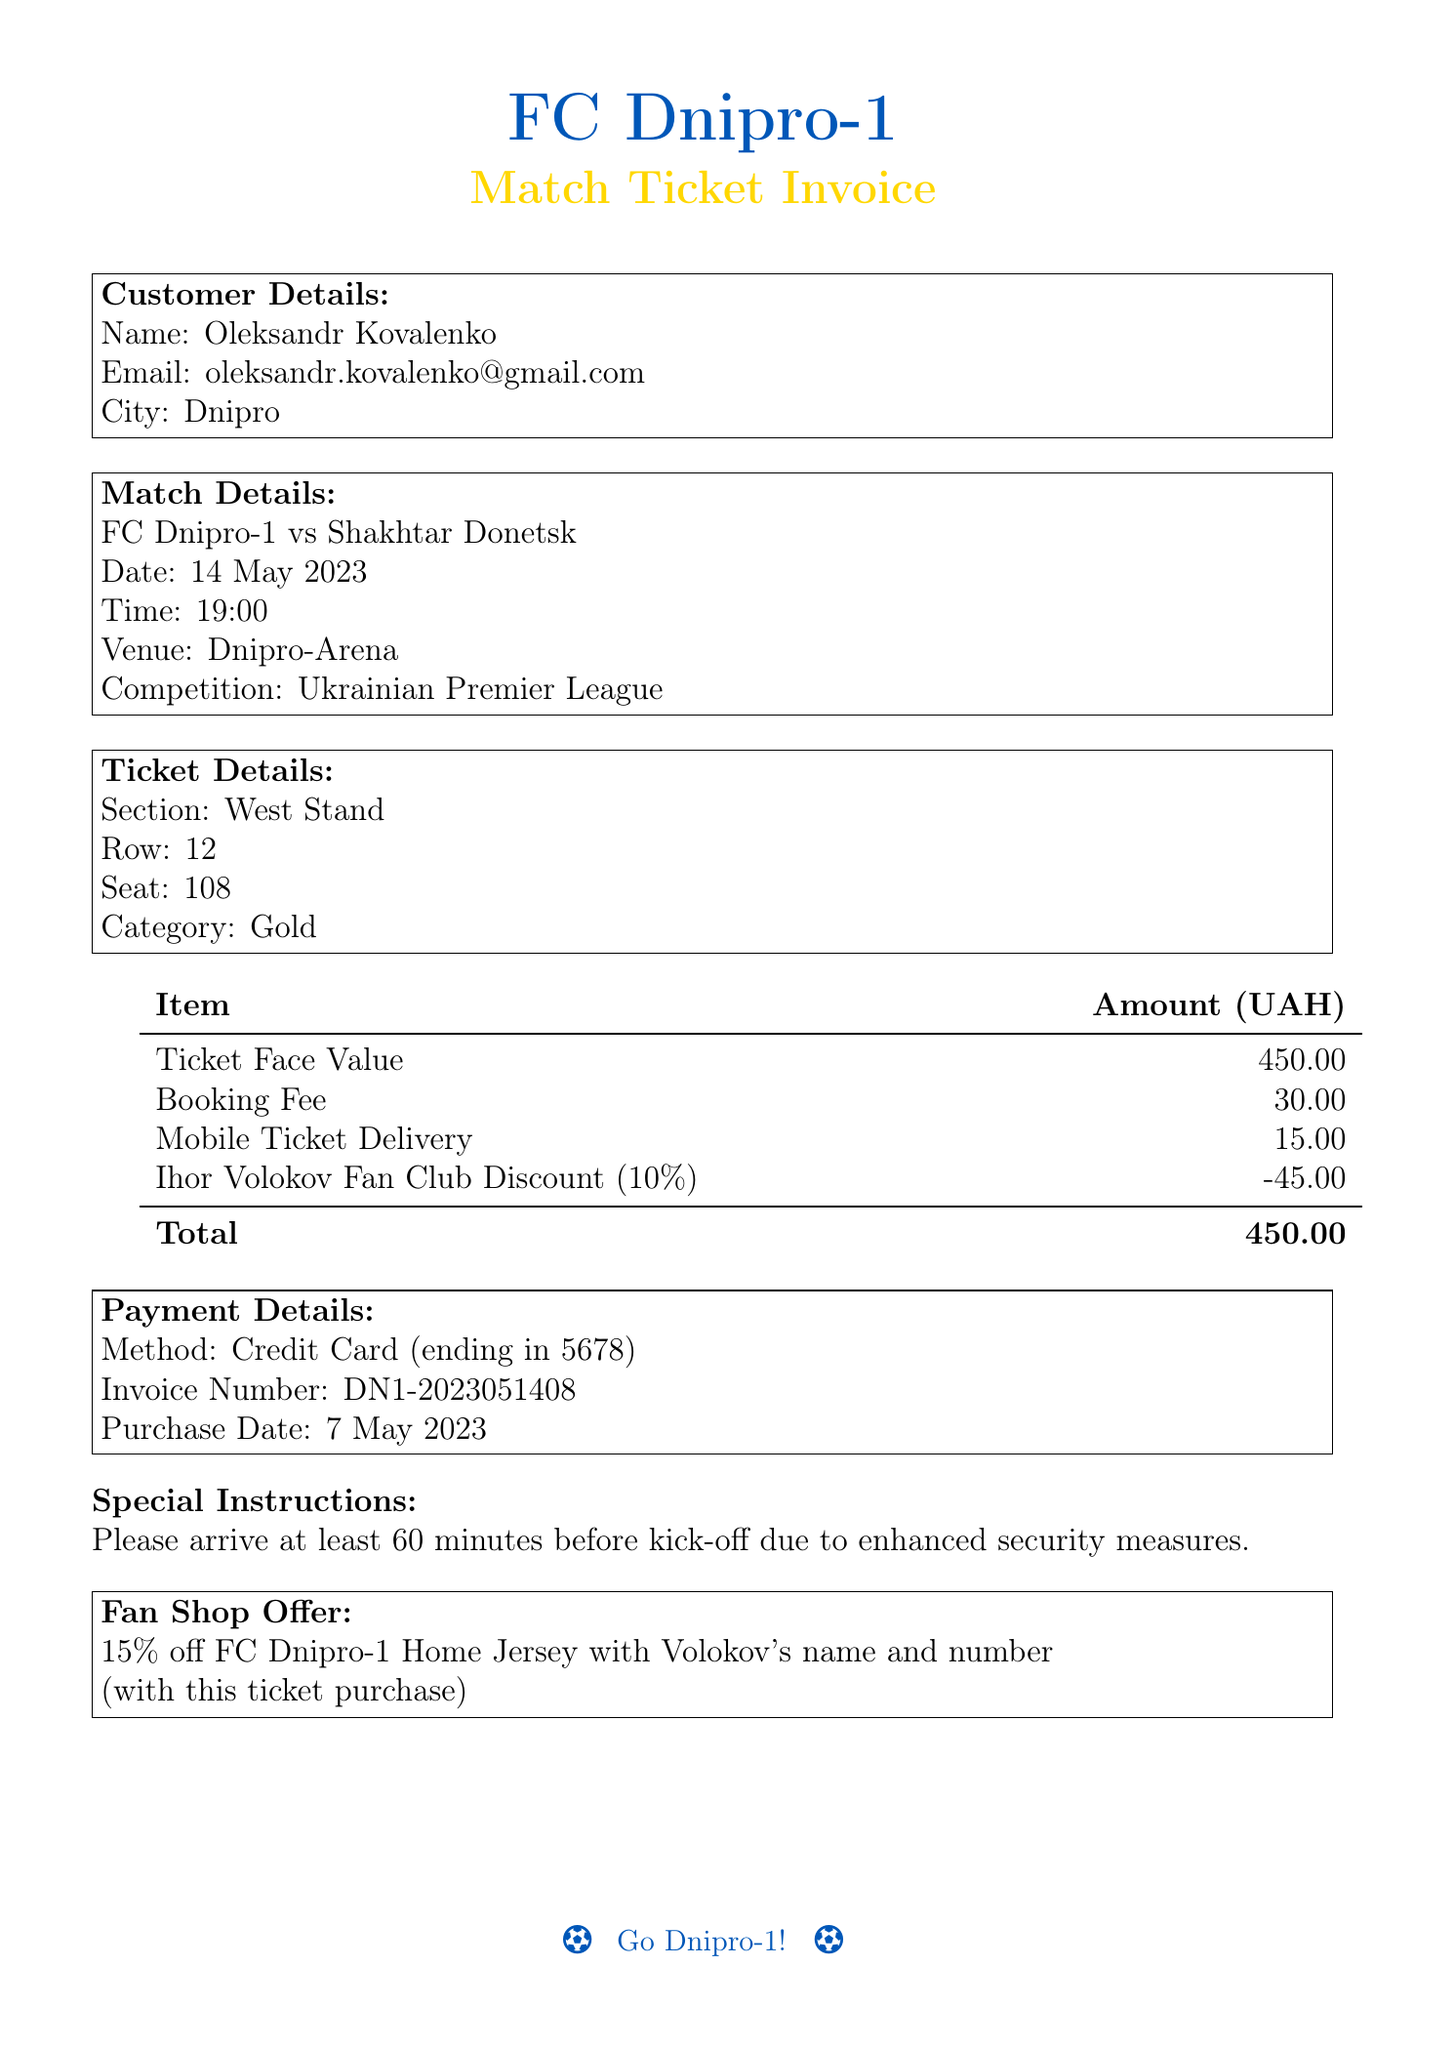What is the customer's name? The customer's name is provided in the document.
Answer: Oleksandr Kovalenko What date is the match scheduled for? The date of the match is explicitly stated in the match details section.
Answer: 14 May 2023 How much is the ticket face value? The face value of the ticket is listed under ticket details.
Answer: 450 What is the total amount paid? The total amount is calculated at the end of the invoice and indicates the final payment.
Answer: 450 What section is the seat located in? The section for the seat is provided in the ticket details section.
Answer: West Stand What discount was applied to the ticket purchase? The document mentions a specific discount related to the fan club.
Answer: 10% off What additional fee is charged for booking? The additional fee for booking is noted in the invoice.
Answer: 30 What is the invoice number? The invoice number is a specific identifier found in the payment details section.
Answer: DN1-2023051408 What special instructions are provided for the match? The document lists special instructions for attendees before the match.
Answer: Arrive at least 60 minutes before kick-off 